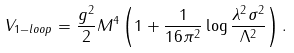<formula> <loc_0><loc_0><loc_500><loc_500>V _ { 1 - l o o p } = \frac { g ^ { 2 } } { 2 } M ^ { 4 } \left ( 1 + \frac { 1 } { 1 6 \pi ^ { 2 } } \log \frac { \lambda ^ { 2 } \sigma ^ { 2 } } { \Lambda ^ { 2 } } \right ) .</formula> 